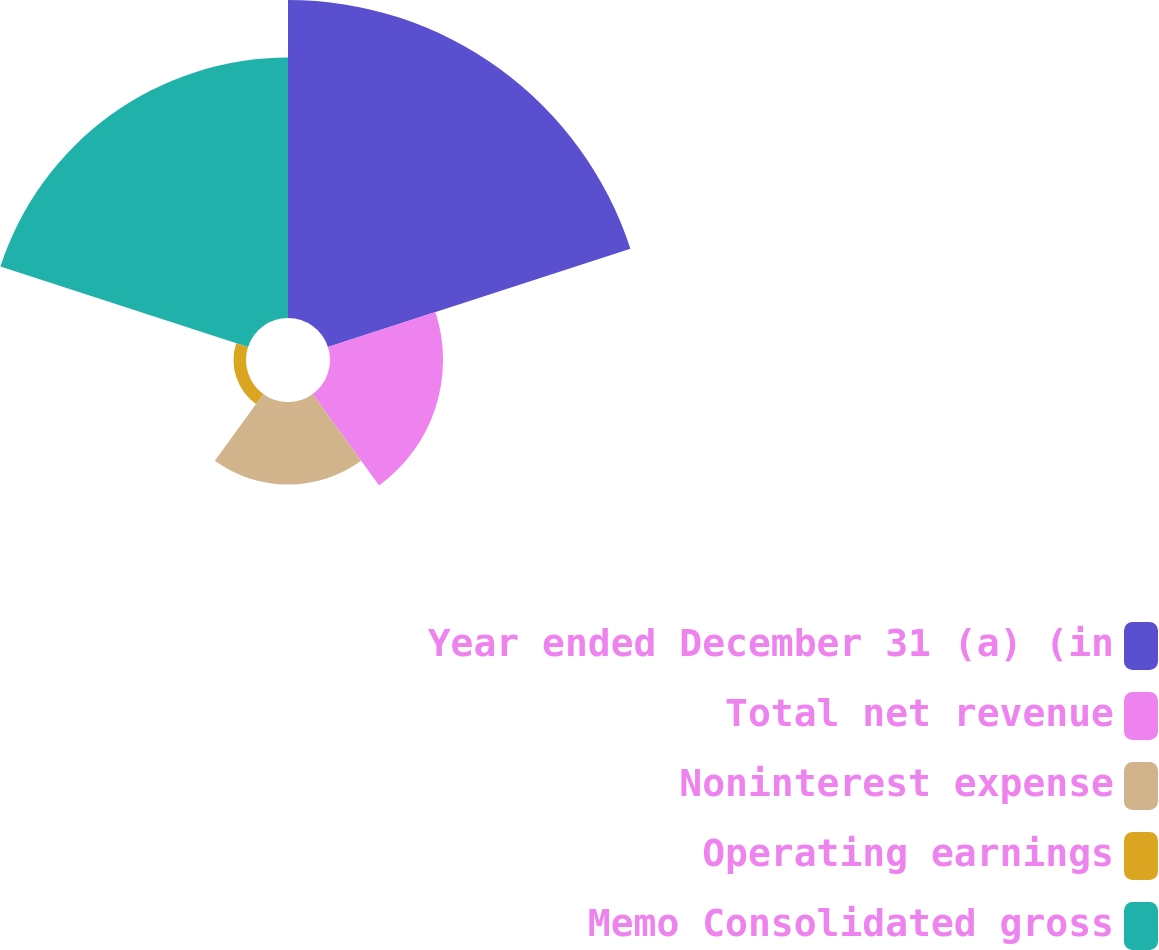Convert chart. <chart><loc_0><loc_0><loc_500><loc_500><pie_chart><fcel>Year ended December 31 (a) (in<fcel>Total net revenue<fcel>Noninterest expense<fcel>Operating earnings<fcel>Memo Consolidated gross<nl><fcel>40.43%<fcel>14.37%<fcel>10.49%<fcel>1.59%<fcel>33.11%<nl></chart> 